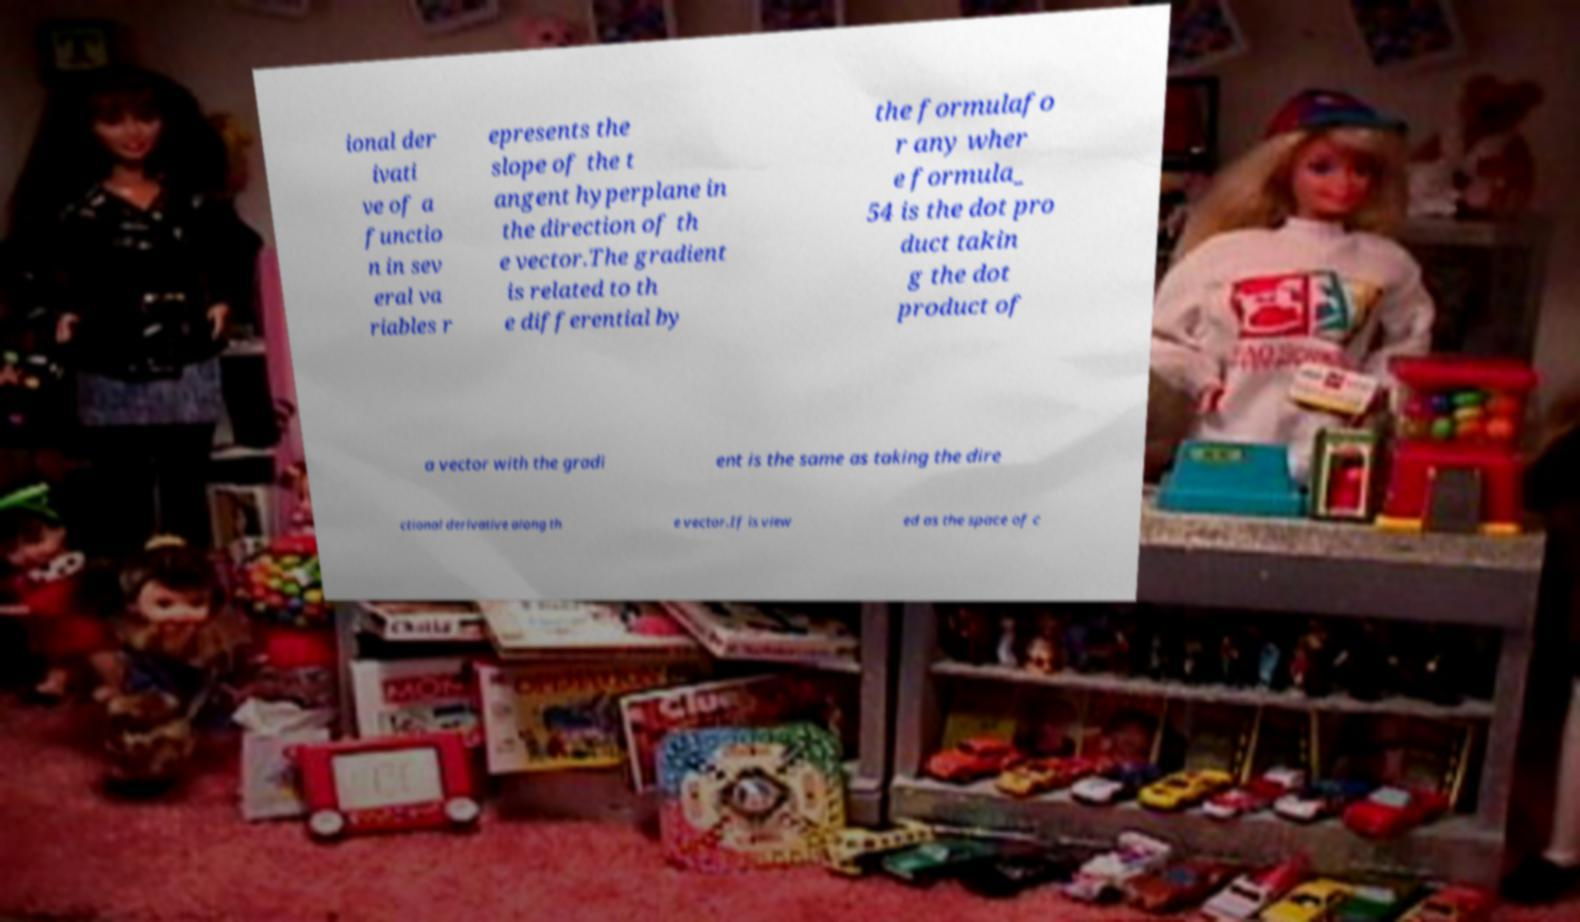I need the written content from this picture converted into text. Can you do that? ional der ivati ve of a functio n in sev eral va riables r epresents the slope of the t angent hyperplane in the direction of th e vector.The gradient is related to th e differential by the formulafo r any wher e formula_ 54 is the dot pro duct takin g the dot product of a vector with the gradi ent is the same as taking the dire ctional derivative along th e vector.If is view ed as the space of c 